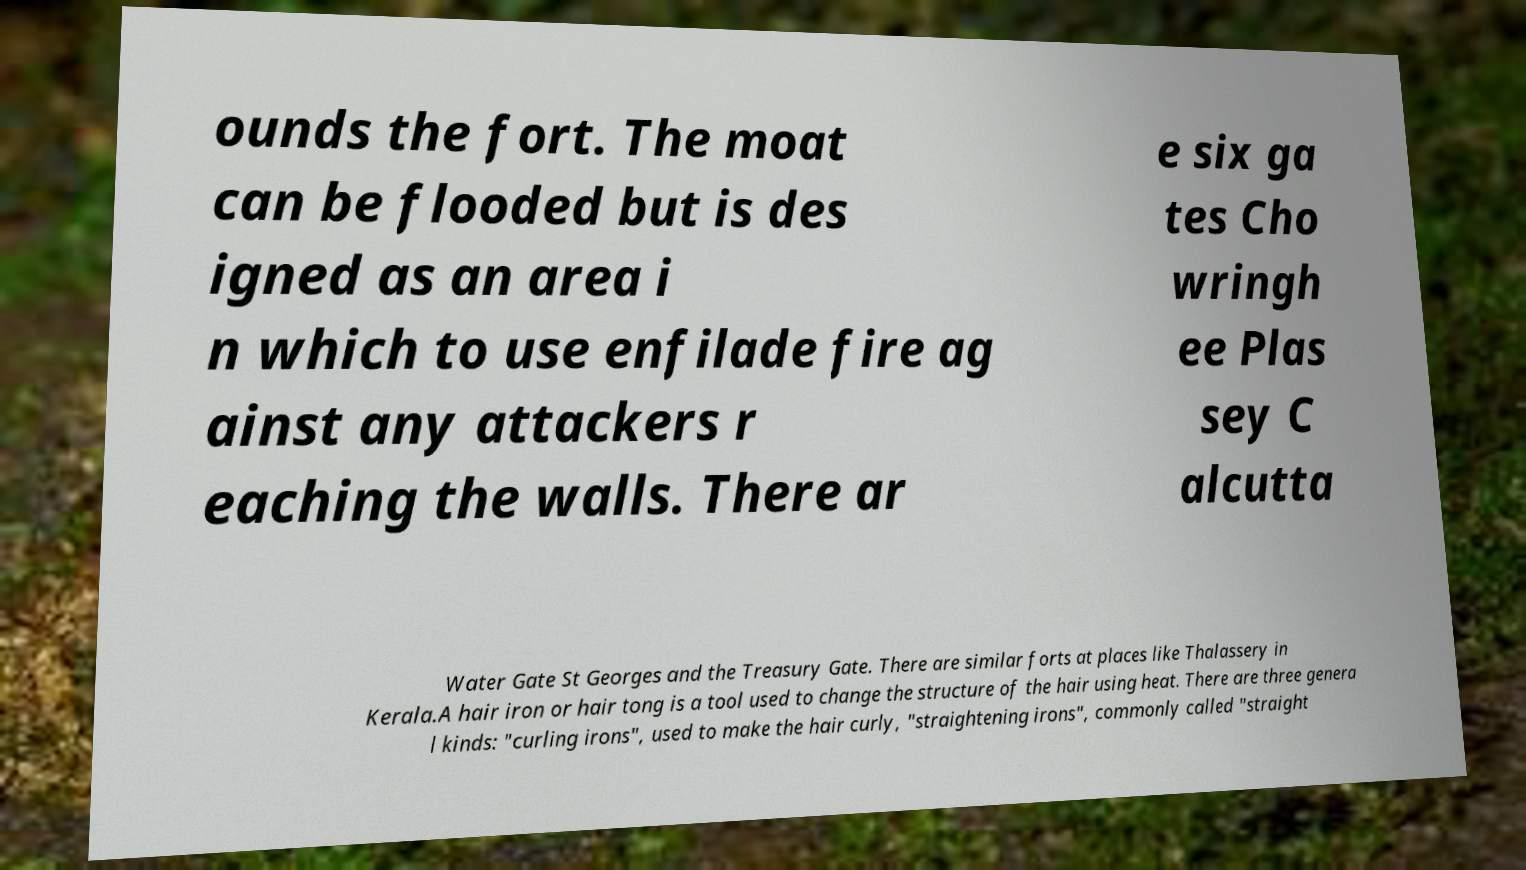Please identify and transcribe the text found in this image. ounds the fort. The moat can be flooded but is des igned as an area i n which to use enfilade fire ag ainst any attackers r eaching the walls. There ar e six ga tes Cho wringh ee Plas sey C alcutta Water Gate St Georges and the Treasury Gate. There are similar forts at places like Thalassery in Kerala.A hair iron or hair tong is a tool used to change the structure of the hair using heat. There are three genera l kinds: "curling irons", used to make the hair curly, "straightening irons", commonly called "straight 